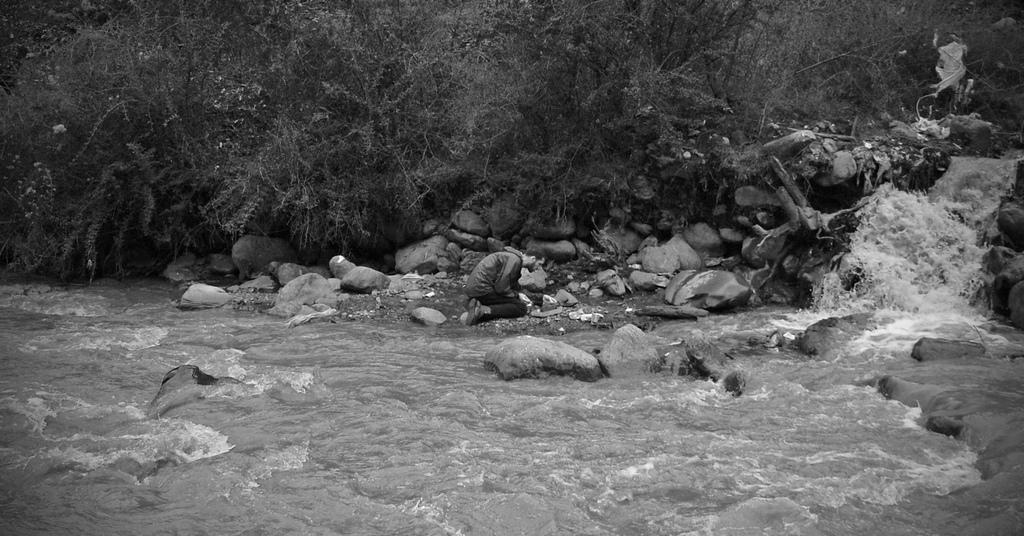What is happening in the image? There is a water flow in the image, and a person is kneeling down near it. What can be seen in the background of the image? There are trees visible in the background of the image. What type of vest is the person wearing near the water flow? There is no information about a vest in the image, so we cannot determine if the person is wearing one or what type it might be. What season is it in the image, given the presence of a spring? There is no mention of a spring in the image, so we cannot determine the season based on this information. 